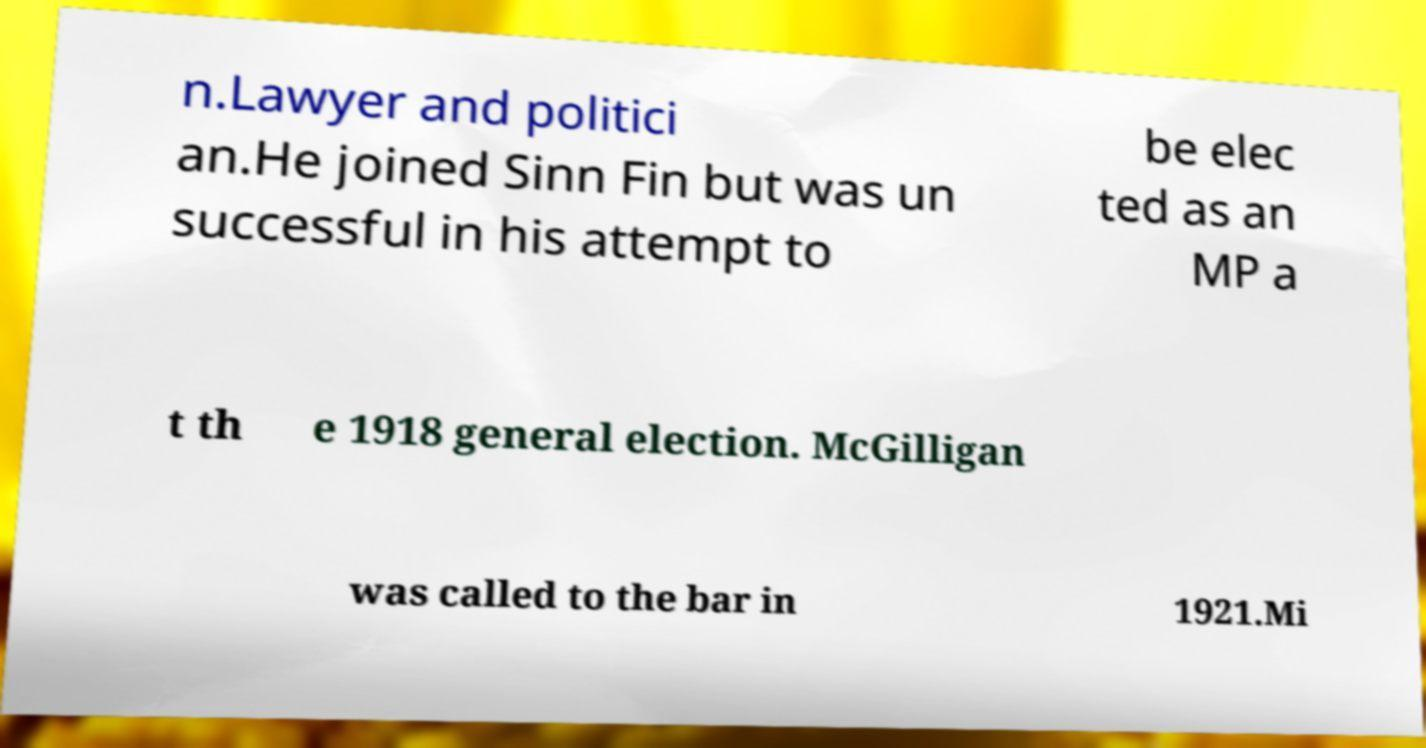Can you read and provide the text displayed in the image?This photo seems to have some interesting text. Can you extract and type it out for me? n.Lawyer and politici an.He joined Sinn Fin but was un successful in his attempt to be elec ted as an MP a t th e 1918 general election. McGilligan was called to the bar in 1921.Mi 